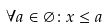<formula> <loc_0><loc_0><loc_500><loc_500>\forall a \in \varnothing \colon x \leq a</formula> 